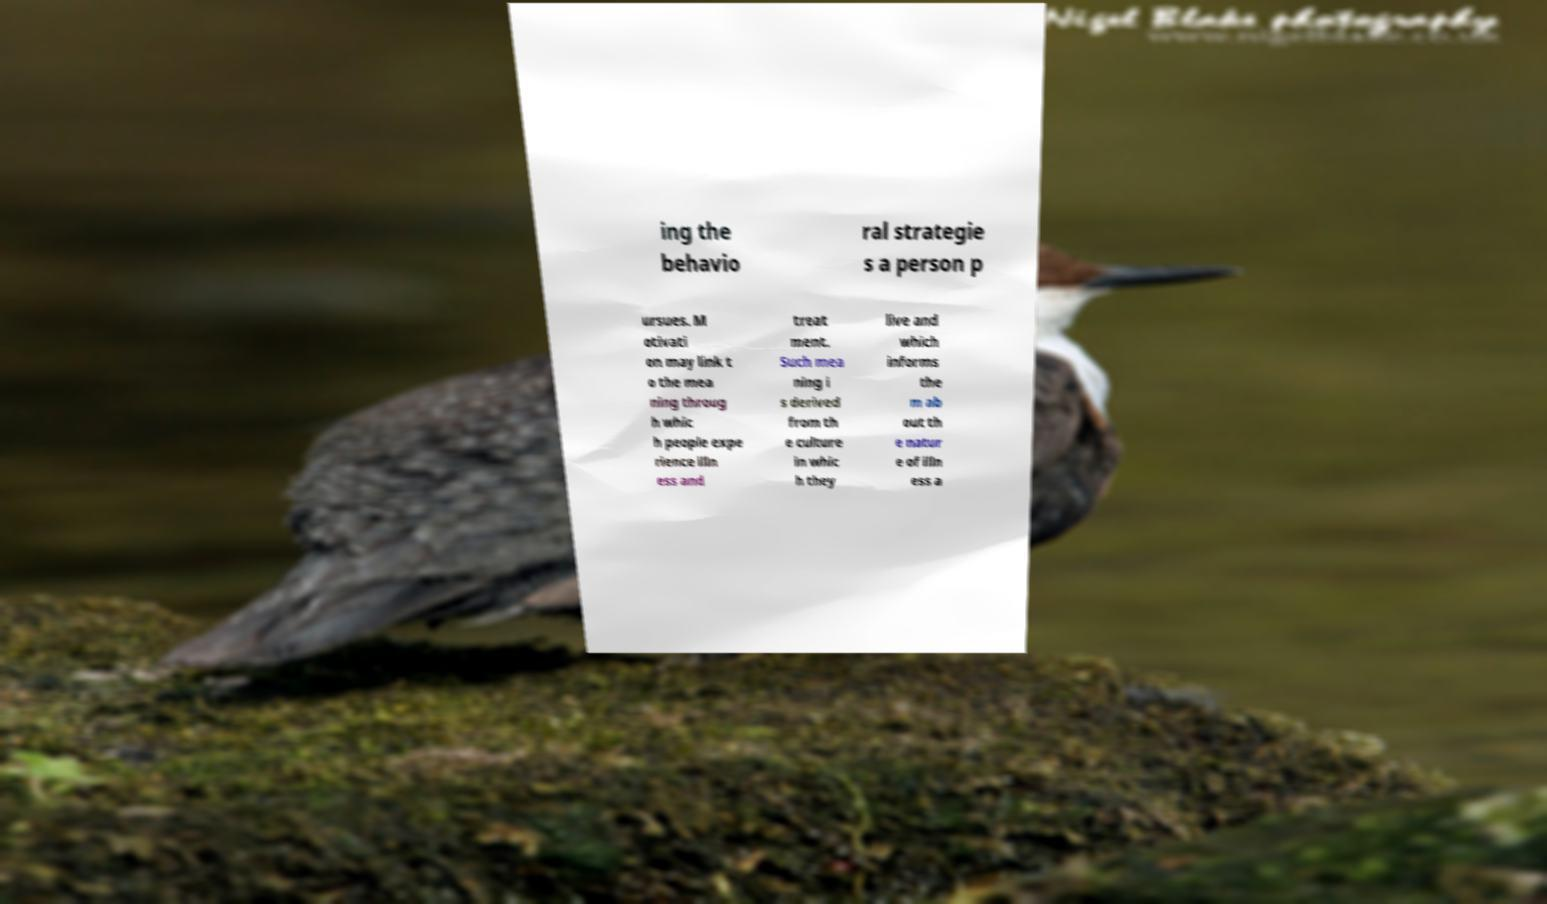I need the written content from this picture converted into text. Can you do that? ing the behavio ral strategie s a person p ursues. M otivati on may link t o the mea ning throug h whic h people expe rience illn ess and treat ment. Such mea ning i s derived from th e culture in whic h they live and which informs the m ab out th e natur e of illn ess a 